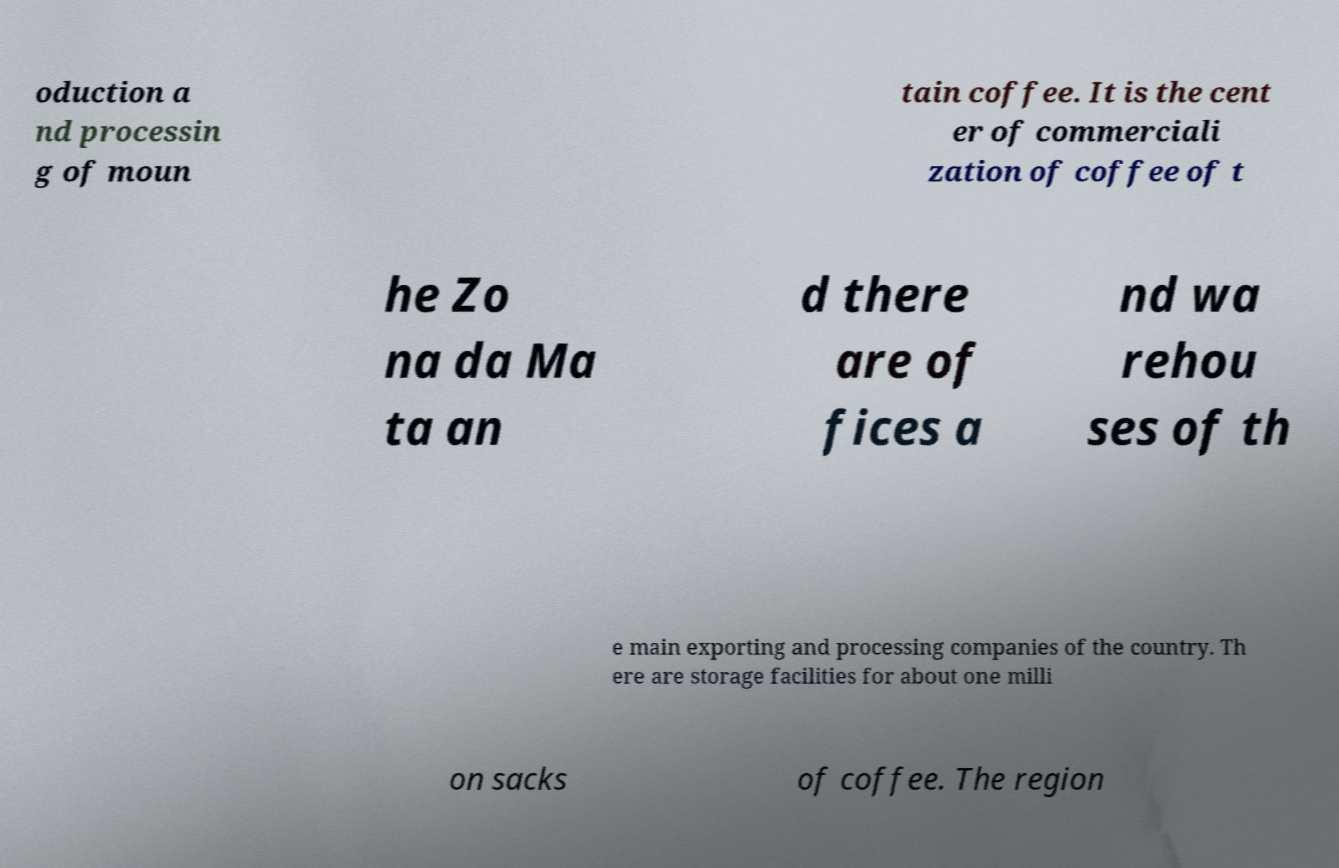I need the written content from this picture converted into text. Can you do that? oduction a nd processin g of moun tain coffee. It is the cent er of commerciali zation of coffee of t he Zo na da Ma ta an d there are of fices a nd wa rehou ses of th e main exporting and processing companies of the country. Th ere are storage facilities for about one milli on sacks of coffee. The region 